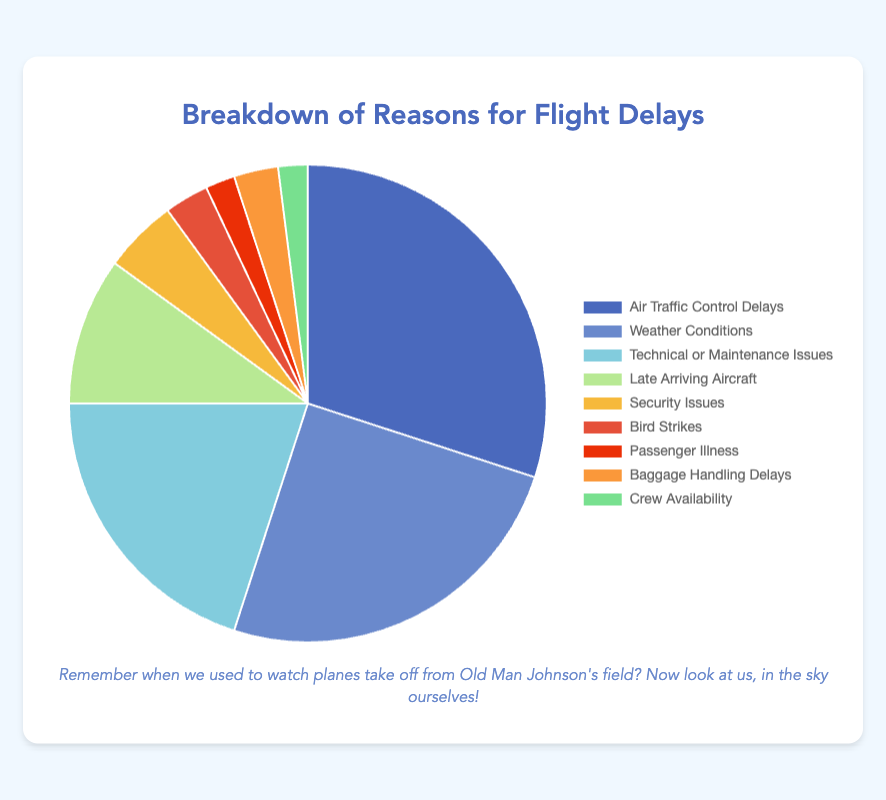Which reason for flight delays has the highest percentage? The chart shows that "Air Traffic Control Delays" has the highest percentage slice, with its portion being significant compared to others.
Answer: Air Traffic Control Delays How does the percentage for Weather Conditions compare to Technical or Maintenance Issues? Weather Conditions account for 25%, while Technical or Maintenance Issues account for 20%. A simple comparison shows that Weather Conditions is 5% higher.
Answer: Weather Conditions is 5% higher What is the combined percentage of delays due to Air Traffic Control and Weather Conditions? Sum the individual percentages: 30% (Air Traffic Control Delays) + 25% (Weather Conditions) = 55%.
Answer: 55% How many delay reasons account for percentages less than 5%? Look at each segment in the pie chart and count those under 5%. Security Issues (5%), Bird Strikes (3%), Passenger Illness (2%), Baggage Handling Delays (3%), and Crew Availability (2%) fall into this category (exactly 5%). This results in four reasons.
Answer: 5 Which segment of the chart is represented in green, and what percentage does it depict? Locate the slice colored green on the pie chart. This color represents "Baggage Handling Delays," which accounts for 3%.
Answer: Baggage Handling Delays, 3% Are delays due to Late Arriving Aircraft more or less than twice those due to Bird Strikes? Late Arriving Aircraft account for 10%, while Bird Strikes account for 3%. Twice the percentage for Bird Strikes would be 6%. Therefore, 10% (Late Arriving Aircraft) is greater than 6%.
Answer: More Combine the percentages of the smallest three reasons for delays. What is the total? Identify the smallest three: Passenger Illness (2%), Crew Availability (2%), and Bird Strikes (3%). Combine these: 2% + 2% + 3% = 7%.
Answer: 7% Which types of delays are less than or equal to those caused by Security Issues? Security Issues account for 5%. The reasons with percentages less than or equal to 5% include Bird Strikes (3%), Passenger Illness (2%), Baggage Handling Delays (3%), and Crew Availability (2%).
Answer: Bird Strikes, Passenger Illness, Baggage Handling Delays, Crew Availability Of the reasons for delays, which are colored in shades of blue, and what are their percentages? Identify the blue shades in the chart: Air Traffic Control Delays (30%), Weather Conditions (25%), and Technical or Maintenance Issues (20%).
Answer: Air Traffic Control Delays, 30%; Weather Conditions, 25%; Technical or Maintenance Issues, 20% 